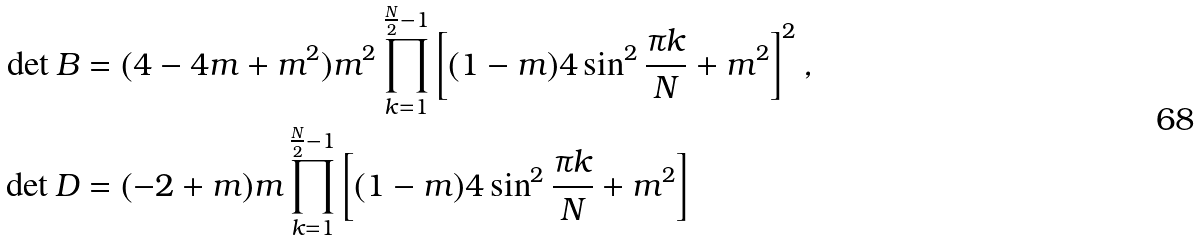Convert formula to latex. <formula><loc_0><loc_0><loc_500><loc_500>\det B & = ( 4 - 4 m + m ^ { 2 } ) m ^ { 2 } \prod _ { k = 1 } ^ { \frac { N } { 2 } - 1 } \left [ ( 1 - m ) 4 \sin ^ { 2 } \frac { \pi k } { N } + m ^ { 2 } \right ] ^ { 2 } , \\ \det D & = ( - 2 + m ) m \prod _ { k = 1 } ^ { \frac { N } { 2 } - 1 } \left [ ( 1 - m ) 4 \sin ^ { 2 } \frac { \pi k } { N } + m ^ { 2 } \right ]</formula> 